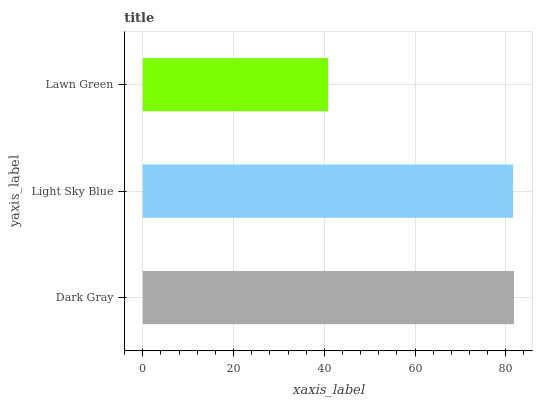Is Lawn Green the minimum?
Answer yes or no. Yes. Is Dark Gray the maximum?
Answer yes or no. Yes. Is Light Sky Blue the minimum?
Answer yes or no. No. Is Light Sky Blue the maximum?
Answer yes or no. No. Is Dark Gray greater than Light Sky Blue?
Answer yes or no. Yes. Is Light Sky Blue less than Dark Gray?
Answer yes or no. Yes. Is Light Sky Blue greater than Dark Gray?
Answer yes or no. No. Is Dark Gray less than Light Sky Blue?
Answer yes or no. No. Is Light Sky Blue the high median?
Answer yes or no. Yes. Is Light Sky Blue the low median?
Answer yes or no. Yes. Is Lawn Green the high median?
Answer yes or no. No. Is Lawn Green the low median?
Answer yes or no. No. 